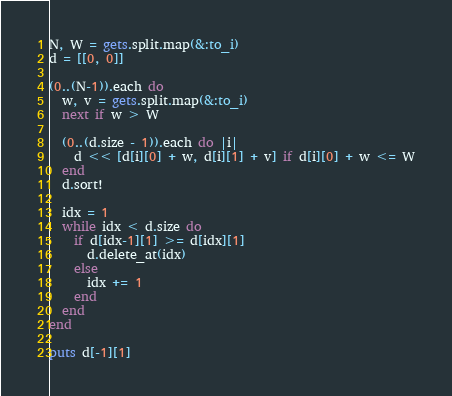<code> <loc_0><loc_0><loc_500><loc_500><_Ruby_>N, W = gets.split.map(&:to_i)
d = [[0, 0]]

(0..(N-1)).each do
  w, v = gets.split.map(&:to_i)
  next if w > W
  
  (0..(d.size - 1)).each do |i|
    d << [d[i][0] + w, d[i][1] + v] if d[i][0] + w <= W
  end
  d.sort!
  
  idx = 1
  while idx < d.size do
    if d[idx-1][1] >= d[idx][1]
      d.delete_at(idx)
    else
      idx += 1
    end
  end
end

puts d[-1][1]</code> 